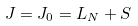<formula> <loc_0><loc_0><loc_500><loc_500>J = J _ { 0 } = L _ { N } + S</formula> 